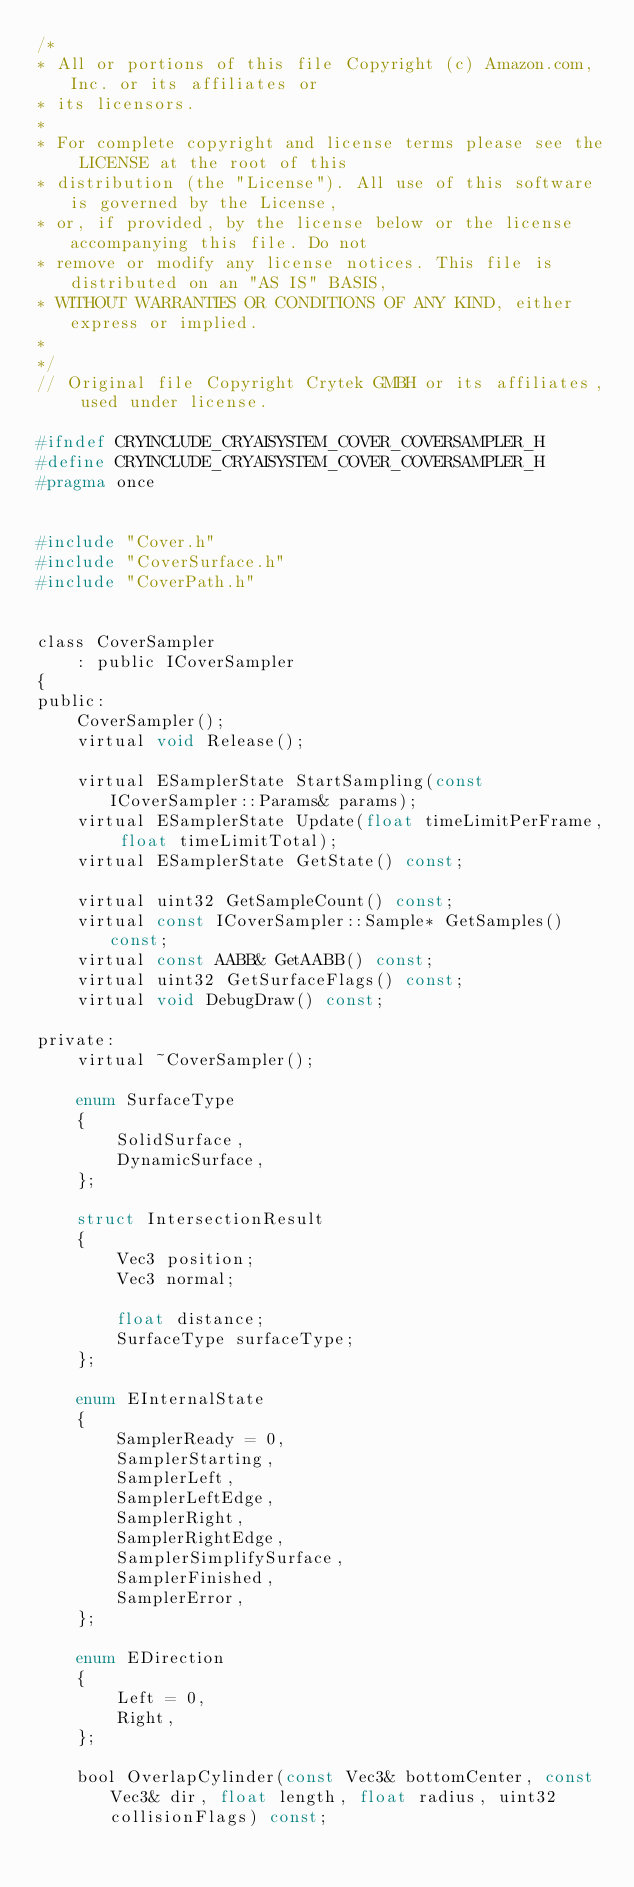Convert code to text. <code><loc_0><loc_0><loc_500><loc_500><_C_>/*
* All or portions of this file Copyright (c) Amazon.com, Inc. or its affiliates or
* its licensors.
*
* For complete copyright and license terms please see the LICENSE at the root of this
* distribution (the "License"). All use of this software is governed by the License,
* or, if provided, by the license below or the license accompanying this file. Do not
* remove or modify any license notices. This file is distributed on an "AS IS" BASIS,
* WITHOUT WARRANTIES OR CONDITIONS OF ANY KIND, either express or implied.
*
*/
// Original file Copyright Crytek GMBH or its affiliates, used under license.

#ifndef CRYINCLUDE_CRYAISYSTEM_COVER_COVERSAMPLER_H
#define CRYINCLUDE_CRYAISYSTEM_COVER_COVERSAMPLER_H
#pragma once


#include "Cover.h"
#include "CoverSurface.h"
#include "CoverPath.h"


class CoverSampler
    : public ICoverSampler
{
public:
    CoverSampler();
    virtual void Release();

    virtual ESamplerState StartSampling(const ICoverSampler::Params& params);
    virtual ESamplerState Update(float timeLimitPerFrame, float timeLimitTotal);
    virtual ESamplerState GetState() const;

    virtual uint32 GetSampleCount() const;
    virtual const ICoverSampler::Sample* GetSamples() const;
    virtual const AABB& GetAABB() const;
    virtual uint32 GetSurfaceFlags() const;
    virtual void DebugDraw() const;

private:
    virtual ~CoverSampler();

    enum SurfaceType
    {
        SolidSurface,
        DynamicSurface,
    };

    struct IntersectionResult
    {
        Vec3 position;
        Vec3 normal;

        float distance;
        SurfaceType surfaceType;
    };

    enum EInternalState
    {
        SamplerReady = 0,
        SamplerStarting,
        SamplerLeft,
        SamplerLeftEdge,
        SamplerRight,
        SamplerRightEdge,
        SamplerSimplifySurface,
        SamplerFinished,
        SamplerError,
    };

    enum EDirection
    {
        Left = 0,
        Right,
    };

    bool OverlapCylinder(const Vec3& bottomCenter, const Vec3& dir, float length, float radius, uint32 collisionFlags) const;</code> 